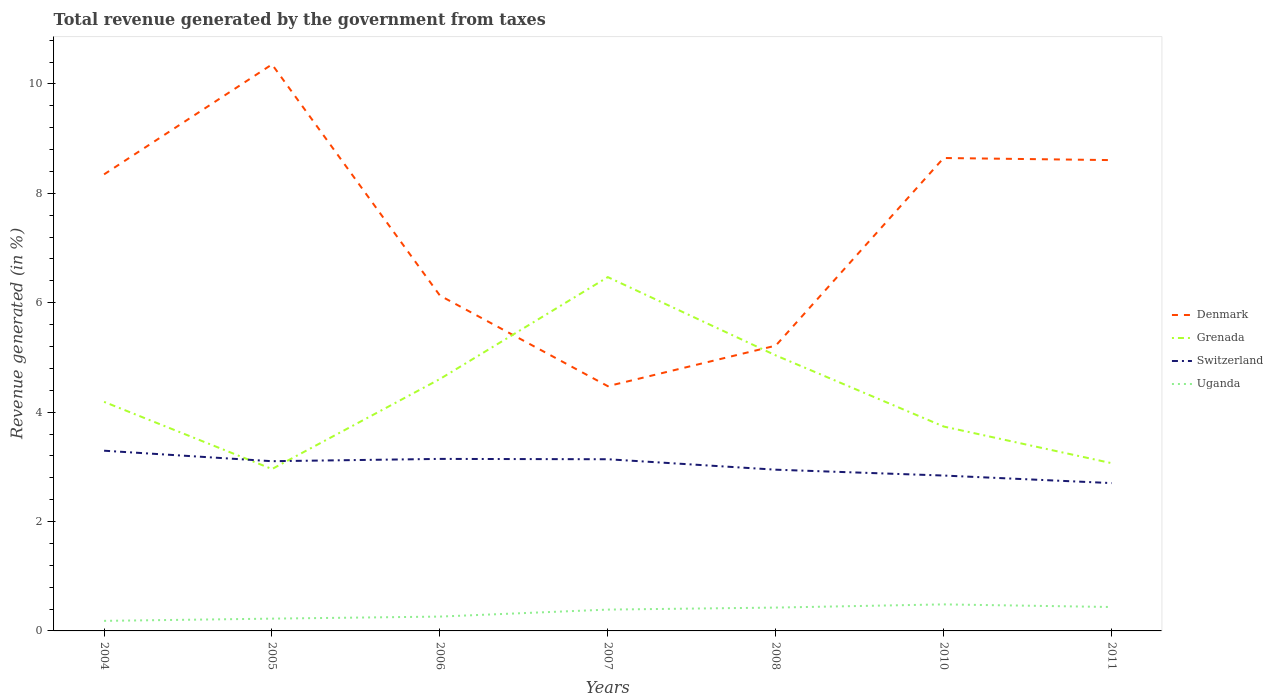How many different coloured lines are there?
Give a very brief answer. 4. Does the line corresponding to Denmark intersect with the line corresponding to Switzerland?
Your answer should be compact. No. Across all years, what is the maximum total revenue generated in Grenada?
Offer a very short reply. 2.96. What is the total total revenue generated in Uganda in the graph?
Provide a short and direct response. -0.21. What is the difference between the highest and the second highest total revenue generated in Denmark?
Your answer should be very brief. 5.88. How many lines are there?
Your response must be concise. 4. How many years are there in the graph?
Offer a very short reply. 7. What is the difference between two consecutive major ticks on the Y-axis?
Provide a succinct answer. 2. Does the graph contain any zero values?
Your answer should be compact. No. Where does the legend appear in the graph?
Give a very brief answer. Center right. How many legend labels are there?
Your response must be concise. 4. How are the legend labels stacked?
Offer a very short reply. Vertical. What is the title of the graph?
Your answer should be very brief. Total revenue generated by the government from taxes. What is the label or title of the Y-axis?
Offer a very short reply. Revenue generated (in %). What is the Revenue generated (in %) in Denmark in 2004?
Give a very brief answer. 8.35. What is the Revenue generated (in %) in Grenada in 2004?
Provide a succinct answer. 4.19. What is the Revenue generated (in %) in Switzerland in 2004?
Provide a succinct answer. 3.29. What is the Revenue generated (in %) of Uganda in 2004?
Make the answer very short. 0.18. What is the Revenue generated (in %) of Denmark in 2005?
Offer a terse response. 10.36. What is the Revenue generated (in %) of Grenada in 2005?
Make the answer very short. 2.96. What is the Revenue generated (in %) in Switzerland in 2005?
Offer a terse response. 3.1. What is the Revenue generated (in %) in Uganda in 2005?
Your answer should be compact. 0.22. What is the Revenue generated (in %) of Denmark in 2006?
Offer a very short reply. 6.13. What is the Revenue generated (in %) of Grenada in 2006?
Give a very brief answer. 4.61. What is the Revenue generated (in %) in Switzerland in 2006?
Make the answer very short. 3.15. What is the Revenue generated (in %) of Uganda in 2006?
Offer a terse response. 0.26. What is the Revenue generated (in %) of Denmark in 2007?
Keep it short and to the point. 4.47. What is the Revenue generated (in %) in Grenada in 2007?
Your answer should be compact. 6.47. What is the Revenue generated (in %) in Switzerland in 2007?
Provide a short and direct response. 3.14. What is the Revenue generated (in %) in Uganda in 2007?
Your response must be concise. 0.39. What is the Revenue generated (in %) of Denmark in 2008?
Provide a succinct answer. 5.22. What is the Revenue generated (in %) of Grenada in 2008?
Offer a very short reply. 5.04. What is the Revenue generated (in %) of Switzerland in 2008?
Offer a very short reply. 2.95. What is the Revenue generated (in %) of Uganda in 2008?
Ensure brevity in your answer.  0.43. What is the Revenue generated (in %) of Denmark in 2010?
Your answer should be compact. 8.65. What is the Revenue generated (in %) of Grenada in 2010?
Give a very brief answer. 3.74. What is the Revenue generated (in %) in Switzerland in 2010?
Keep it short and to the point. 2.84. What is the Revenue generated (in %) of Uganda in 2010?
Give a very brief answer. 0.49. What is the Revenue generated (in %) in Denmark in 2011?
Offer a very short reply. 8.61. What is the Revenue generated (in %) of Grenada in 2011?
Provide a short and direct response. 3.07. What is the Revenue generated (in %) in Switzerland in 2011?
Provide a succinct answer. 2.7. What is the Revenue generated (in %) of Uganda in 2011?
Give a very brief answer. 0.44. Across all years, what is the maximum Revenue generated (in %) in Denmark?
Provide a succinct answer. 10.36. Across all years, what is the maximum Revenue generated (in %) of Grenada?
Keep it short and to the point. 6.47. Across all years, what is the maximum Revenue generated (in %) of Switzerland?
Your answer should be very brief. 3.29. Across all years, what is the maximum Revenue generated (in %) of Uganda?
Your answer should be very brief. 0.49. Across all years, what is the minimum Revenue generated (in %) in Denmark?
Offer a very short reply. 4.47. Across all years, what is the minimum Revenue generated (in %) in Grenada?
Ensure brevity in your answer.  2.96. Across all years, what is the minimum Revenue generated (in %) in Switzerland?
Offer a very short reply. 2.7. Across all years, what is the minimum Revenue generated (in %) of Uganda?
Offer a very short reply. 0.18. What is the total Revenue generated (in %) in Denmark in the graph?
Provide a succinct answer. 51.78. What is the total Revenue generated (in %) in Grenada in the graph?
Provide a short and direct response. 30.06. What is the total Revenue generated (in %) of Switzerland in the graph?
Make the answer very short. 21.17. What is the total Revenue generated (in %) of Uganda in the graph?
Provide a short and direct response. 2.41. What is the difference between the Revenue generated (in %) of Denmark in 2004 and that in 2005?
Your answer should be very brief. -2.01. What is the difference between the Revenue generated (in %) in Grenada in 2004 and that in 2005?
Keep it short and to the point. 1.23. What is the difference between the Revenue generated (in %) in Switzerland in 2004 and that in 2005?
Ensure brevity in your answer.  0.19. What is the difference between the Revenue generated (in %) of Uganda in 2004 and that in 2005?
Provide a succinct answer. -0.04. What is the difference between the Revenue generated (in %) of Denmark in 2004 and that in 2006?
Your answer should be very brief. 2.22. What is the difference between the Revenue generated (in %) of Grenada in 2004 and that in 2006?
Offer a very short reply. -0.42. What is the difference between the Revenue generated (in %) of Switzerland in 2004 and that in 2006?
Make the answer very short. 0.15. What is the difference between the Revenue generated (in %) of Uganda in 2004 and that in 2006?
Offer a terse response. -0.08. What is the difference between the Revenue generated (in %) of Denmark in 2004 and that in 2007?
Your answer should be compact. 3.87. What is the difference between the Revenue generated (in %) of Grenada in 2004 and that in 2007?
Keep it short and to the point. -2.28. What is the difference between the Revenue generated (in %) in Switzerland in 2004 and that in 2007?
Provide a succinct answer. 0.16. What is the difference between the Revenue generated (in %) in Uganda in 2004 and that in 2007?
Provide a short and direct response. -0.21. What is the difference between the Revenue generated (in %) of Denmark in 2004 and that in 2008?
Make the answer very short. 3.13. What is the difference between the Revenue generated (in %) in Grenada in 2004 and that in 2008?
Offer a very short reply. -0.85. What is the difference between the Revenue generated (in %) in Switzerland in 2004 and that in 2008?
Offer a very short reply. 0.35. What is the difference between the Revenue generated (in %) of Uganda in 2004 and that in 2008?
Give a very brief answer. -0.24. What is the difference between the Revenue generated (in %) of Denmark in 2004 and that in 2010?
Keep it short and to the point. -0.3. What is the difference between the Revenue generated (in %) in Grenada in 2004 and that in 2010?
Your response must be concise. 0.45. What is the difference between the Revenue generated (in %) of Switzerland in 2004 and that in 2010?
Offer a terse response. 0.45. What is the difference between the Revenue generated (in %) in Uganda in 2004 and that in 2010?
Provide a succinct answer. -0.3. What is the difference between the Revenue generated (in %) in Denmark in 2004 and that in 2011?
Your response must be concise. -0.26. What is the difference between the Revenue generated (in %) in Grenada in 2004 and that in 2011?
Offer a very short reply. 1.12. What is the difference between the Revenue generated (in %) in Switzerland in 2004 and that in 2011?
Provide a succinct answer. 0.59. What is the difference between the Revenue generated (in %) of Uganda in 2004 and that in 2011?
Offer a terse response. -0.25. What is the difference between the Revenue generated (in %) of Denmark in 2005 and that in 2006?
Keep it short and to the point. 4.23. What is the difference between the Revenue generated (in %) in Grenada in 2005 and that in 2006?
Give a very brief answer. -1.65. What is the difference between the Revenue generated (in %) of Switzerland in 2005 and that in 2006?
Keep it short and to the point. -0.04. What is the difference between the Revenue generated (in %) of Uganda in 2005 and that in 2006?
Provide a succinct answer. -0.04. What is the difference between the Revenue generated (in %) of Denmark in 2005 and that in 2007?
Provide a succinct answer. 5.88. What is the difference between the Revenue generated (in %) of Grenada in 2005 and that in 2007?
Keep it short and to the point. -3.51. What is the difference between the Revenue generated (in %) in Switzerland in 2005 and that in 2007?
Give a very brief answer. -0.04. What is the difference between the Revenue generated (in %) of Uganda in 2005 and that in 2007?
Keep it short and to the point. -0.17. What is the difference between the Revenue generated (in %) in Denmark in 2005 and that in 2008?
Keep it short and to the point. 5.14. What is the difference between the Revenue generated (in %) of Grenada in 2005 and that in 2008?
Offer a terse response. -2.08. What is the difference between the Revenue generated (in %) in Switzerland in 2005 and that in 2008?
Your response must be concise. 0.16. What is the difference between the Revenue generated (in %) of Uganda in 2005 and that in 2008?
Your answer should be very brief. -0.2. What is the difference between the Revenue generated (in %) in Denmark in 2005 and that in 2010?
Your response must be concise. 1.71. What is the difference between the Revenue generated (in %) in Grenada in 2005 and that in 2010?
Ensure brevity in your answer.  -0.78. What is the difference between the Revenue generated (in %) of Switzerland in 2005 and that in 2010?
Your response must be concise. 0.26. What is the difference between the Revenue generated (in %) in Uganda in 2005 and that in 2010?
Offer a terse response. -0.26. What is the difference between the Revenue generated (in %) of Denmark in 2005 and that in 2011?
Offer a terse response. 1.75. What is the difference between the Revenue generated (in %) of Grenada in 2005 and that in 2011?
Your answer should be very brief. -0.11. What is the difference between the Revenue generated (in %) of Switzerland in 2005 and that in 2011?
Your response must be concise. 0.4. What is the difference between the Revenue generated (in %) of Uganda in 2005 and that in 2011?
Give a very brief answer. -0.21. What is the difference between the Revenue generated (in %) in Denmark in 2006 and that in 2007?
Offer a terse response. 1.66. What is the difference between the Revenue generated (in %) in Grenada in 2006 and that in 2007?
Your response must be concise. -1.86. What is the difference between the Revenue generated (in %) of Switzerland in 2006 and that in 2007?
Ensure brevity in your answer.  0.01. What is the difference between the Revenue generated (in %) of Uganda in 2006 and that in 2007?
Provide a short and direct response. -0.13. What is the difference between the Revenue generated (in %) in Denmark in 2006 and that in 2008?
Make the answer very short. 0.92. What is the difference between the Revenue generated (in %) of Grenada in 2006 and that in 2008?
Give a very brief answer. -0.43. What is the difference between the Revenue generated (in %) in Switzerland in 2006 and that in 2008?
Your answer should be compact. 0.2. What is the difference between the Revenue generated (in %) in Uganda in 2006 and that in 2008?
Provide a short and direct response. -0.16. What is the difference between the Revenue generated (in %) of Denmark in 2006 and that in 2010?
Your answer should be very brief. -2.51. What is the difference between the Revenue generated (in %) in Grenada in 2006 and that in 2010?
Ensure brevity in your answer.  0.87. What is the difference between the Revenue generated (in %) of Switzerland in 2006 and that in 2010?
Ensure brevity in your answer.  0.3. What is the difference between the Revenue generated (in %) in Uganda in 2006 and that in 2010?
Your response must be concise. -0.22. What is the difference between the Revenue generated (in %) in Denmark in 2006 and that in 2011?
Your response must be concise. -2.48. What is the difference between the Revenue generated (in %) of Grenada in 2006 and that in 2011?
Give a very brief answer. 1.54. What is the difference between the Revenue generated (in %) of Switzerland in 2006 and that in 2011?
Offer a very short reply. 0.44. What is the difference between the Revenue generated (in %) of Uganda in 2006 and that in 2011?
Provide a succinct answer. -0.17. What is the difference between the Revenue generated (in %) of Denmark in 2007 and that in 2008?
Offer a terse response. -0.74. What is the difference between the Revenue generated (in %) of Grenada in 2007 and that in 2008?
Your answer should be very brief. 1.43. What is the difference between the Revenue generated (in %) in Switzerland in 2007 and that in 2008?
Provide a succinct answer. 0.19. What is the difference between the Revenue generated (in %) in Uganda in 2007 and that in 2008?
Your answer should be compact. -0.04. What is the difference between the Revenue generated (in %) of Denmark in 2007 and that in 2010?
Provide a short and direct response. -4.17. What is the difference between the Revenue generated (in %) in Grenada in 2007 and that in 2010?
Your answer should be very brief. 2.73. What is the difference between the Revenue generated (in %) in Switzerland in 2007 and that in 2010?
Make the answer very short. 0.3. What is the difference between the Revenue generated (in %) in Uganda in 2007 and that in 2010?
Provide a succinct answer. -0.1. What is the difference between the Revenue generated (in %) in Denmark in 2007 and that in 2011?
Your answer should be compact. -4.13. What is the difference between the Revenue generated (in %) of Grenada in 2007 and that in 2011?
Provide a succinct answer. 3.4. What is the difference between the Revenue generated (in %) of Switzerland in 2007 and that in 2011?
Offer a terse response. 0.44. What is the difference between the Revenue generated (in %) in Uganda in 2007 and that in 2011?
Your answer should be compact. -0.05. What is the difference between the Revenue generated (in %) of Denmark in 2008 and that in 2010?
Provide a succinct answer. -3.43. What is the difference between the Revenue generated (in %) in Grenada in 2008 and that in 2010?
Your answer should be compact. 1.3. What is the difference between the Revenue generated (in %) of Switzerland in 2008 and that in 2010?
Make the answer very short. 0.11. What is the difference between the Revenue generated (in %) in Uganda in 2008 and that in 2010?
Give a very brief answer. -0.06. What is the difference between the Revenue generated (in %) in Denmark in 2008 and that in 2011?
Give a very brief answer. -3.39. What is the difference between the Revenue generated (in %) of Grenada in 2008 and that in 2011?
Keep it short and to the point. 1.97. What is the difference between the Revenue generated (in %) in Switzerland in 2008 and that in 2011?
Your answer should be very brief. 0.24. What is the difference between the Revenue generated (in %) of Uganda in 2008 and that in 2011?
Keep it short and to the point. -0.01. What is the difference between the Revenue generated (in %) in Denmark in 2010 and that in 2011?
Your response must be concise. 0.04. What is the difference between the Revenue generated (in %) of Grenada in 2010 and that in 2011?
Keep it short and to the point. 0.67. What is the difference between the Revenue generated (in %) in Switzerland in 2010 and that in 2011?
Give a very brief answer. 0.14. What is the difference between the Revenue generated (in %) in Uganda in 2010 and that in 2011?
Your response must be concise. 0.05. What is the difference between the Revenue generated (in %) in Denmark in 2004 and the Revenue generated (in %) in Grenada in 2005?
Offer a terse response. 5.39. What is the difference between the Revenue generated (in %) in Denmark in 2004 and the Revenue generated (in %) in Switzerland in 2005?
Provide a short and direct response. 5.24. What is the difference between the Revenue generated (in %) in Denmark in 2004 and the Revenue generated (in %) in Uganda in 2005?
Offer a terse response. 8.12. What is the difference between the Revenue generated (in %) of Grenada in 2004 and the Revenue generated (in %) of Switzerland in 2005?
Provide a succinct answer. 1.08. What is the difference between the Revenue generated (in %) in Grenada in 2004 and the Revenue generated (in %) in Uganda in 2005?
Offer a very short reply. 3.96. What is the difference between the Revenue generated (in %) in Switzerland in 2004 and the Revenue generated (in %) in Uganda in 2005?
Provide a short and direct response. 3.07. What is the difference between the Revenue generated (in %) in Denmark in 2004 and the Revenue generated (in %) in Grenada in 2006?
Your answer should be very brief. 3.74. What is the difference between the Revenue generated (in %) in Denmark in 2004 and the Revenue generated (in %) in Switzerland in 2006?
Give a very brief answer. 5.2. What is the difference between the Revenue generated (in %) of Denmark in 2004 and the Revenue generated (in %) of Uganda in 2006?
Your response must be concise. 8.09. What is the difference between the Revenue generated (in %) of Grenada in 2004 and the Revenue generated (in %) of Switzerland in 2006?
Provide a short and direct response. 1.04. What is the difference between the Revenue generated (in %) in Grenada in 2004 and the Revenue generated (in %) in Uganda in 2006?
Ensure brevity in your answer.  3.93. What is the difference between the Revenue generated (in %) of Switzerland in 2004 and the Revenue generated (in %) of Uganda in 2006?
Keep it short and to the point. 3.03. What is the difference between the Revenue generated (in %) in Denmark in 2004 and the Revenue generated (in %) in Grenada in 2007?
Ensure brevity in your answer.  1.88. What is the difference between the Revenue generated (in %) in Denmark in 2004 and the Revenue generated (in %) in Switzerland in 2007?
Your answer should be very brief. 5.21. What is the difference between the Revenue generated (in %) in Denmark in 2004 and the Revenue generated (in %) in Uganda in 2007?
Provide a succinct answer. 7.96. What is the difference between the Revenue generated (in %) of Grenada in 2004 and the Revenue generated (in %) of Switzerland in 2007?
Ensure brevity in your answer.  1.05. What is the difference between the Revenue generated (in %) of Grenada in 2004 and the Revenue generated (in %) of Uganda in 2007?
Give a very brief answer. 3.8. What is the difference between the Revenue generated (in %) in Switzerland in 2004 and the Revenue generated (in %) in Uganda in 2007?
Ensure brevity in your answer.  2.9. What is the difference between the Revenue generated (in %) in Denmark in 2004 and the Revenue generated (in %) in Grenada in 2008?
Provide a short and direct response. 3.31. What is the difference between the Revenue generated (in %) of Denmark in 2004 and the Revenue generated (in %) of Switzerland in 2008?
Keep it short and to the point. 5.4. What is the difference between the Revenue generated (in %) of Denmark in 2004 and the Revenue generated (in %) of Uganda in 2008?
Your answer should be compact. 7.92. What is the difference between the Revenue generated (in %) of Grenada in 2004 and the Revenue generated (in %) of Switzerland in 2008?
Your answer should be very brief. 1.24. What is the difference between the Revenue generated (in %) in Grenada in 2004 and the Revenue generated (in %) in Uganda in 2008?
Give a very brief answer. 3.76. What is the difference between the Revenue generated (in %) in Switzerland in 2004 and the Revenue generated (in %) in Uganda in 2008?
Your answer should be compact. 2.87. What is the difference between the Revenue generated (in %) in Denmark in 2004 and the Revenue generated (in %) in Grenada in 2010?
Give a very brief answer. 4.61. What is the difference between the Revenue generated (in %) of Denmark in 2004 and the Revenue generated (in %) of Switzerland in 2010?
Keep it short and to the point. 5.51. What is the difference between the Revenue generated (in %) of Denmark in 2004 and the Revenue generated (in %) of Uganda in 2010?
Your answer should be compact. 7.86. What is the difference between the Revenue generated (in %) of Grenada in 2004 and the Revenue generated (in %) of Switzerland in 2010?
Make the answer very short. 1.35. What is the difference between the Revenue generated (in %) in Grenada in 2004 and the Revenue generated (in %) in Uganda in 2010?
Offer a terse response. 3.7. What is the difference between the Revenue generated (in %) in Switzerland in 2004 and the Revenue generated (in %) in Uganda in 2010?
Your answer should be compact. 2.81. What is the difference between the Revenue generated (in %) of Denmark in 2004 and the Revenue generated (in %) of Grenada in 2011?
Offer a terse response. 5.28. What is the difference between the Revenue generated (in %) in Denmark in 2004 and the Revenue generated (in %) in Switzerland in 2011?
Offer a very short reply. 5.64. What is the difference between the Revenue generated (in %) of Denmark in 2004 and the Revenue generated (in %) of Uganda in 2011?
Your answer should be compact. 7.91. What is the difference between the Revenue generated (in %) of Grenada in 2004 and the Revenue generated (in %) of Switzerland in 2011?
Keep it short and to the point. 1.49. What is the difference between the Revenue generated (in %) of Grenada in 2004 and the Revenue generated (in %) of Uganda in 2011?
Offer a terse response. 3.75. What is the difference between the Revenue generated (in %) in Switzerland in 2004 and the Revenue generated (in %) in Uganda in 2011?
Offer a very short reply. 2.86. What is the difference between the Revenue generated (in %) in Denmark in 2005 and the Revenue generated (in %) in Grenada in 2006?
Your response must be concise. 5.75. What is the difference between the Revenue generated (in %) of Denmark in 2005 and the Revenue generated (in %) of Switzerland in 2006?
Offer a very short reply. 7.21. What is the difference between the Revenue generated (in %) in Denmark in 2005 and the Revenue generated (in %) in Uganda in 2006?
Provide a short and direct response. 10.1. What is the difference between the Revenue generated (in %) of Grenada in 2005 and the Revenue generated (in %) of Switzerland in 2006?
Keep it short and to the point. -0.19. What is the difference between the Revenue generated (in %) in Grenada in 2005 and the Revenue generated (in %) in Uganda in 2006?
Your response must be concise. 2.7. What is the difference between the Revenue generated (in %) in Switzerland in 2005 and the Revenue generated (in %) in Uganda in 2006?
Provide a short and direct response. 2.84. What is the difference between the Revenue generated (in %) of Denmark in 2005 and the Revenue generated (in %) of Grenada in 2007?
Your response must be concise. 3.89. What is the difference between the Revenue generated (in %) of Denmark in 2005 and the Revenue generated (in %) of Switzerland in 2007?
Offer a very short reply. 7.22. What is the difference between the Revenue generated (in %) in Denmark in 2005 and the Revenue generated (in %) in Uganda in 2007?
Offer a very short reply. 9.97. What is the difference between the Revenue generated (in %) in Grenada in 2005 and the Revenue generated (in %) in Switzerland in 2007?
Give a very brief answer. -0.18. What is the difference between the Revenue generated (in %) of Grenada in 2005 and the Revenue generated (in %) of Uganda in 2007?
Your answer should be very brief. 2.57. What is the difference between the Revenue generated (in %) in Switzerland in 2005 and the Revenue generated (in %) in Uganda in 2007?
Offer a terse response. 2.71. What is the difference between the Revenue generated (in %) in Denmark in 2005 and the Revenue generated (in %) in Grenada in 2008?
Make the answer very short. 5.32. What is the difference between the Revenue generated (in %) in Denmark in 2005 and the Revenue generated (in %) in Switzerland in 2008?
Provide a short and direct response. 7.41. What is the difference between the Revenue generated (in %) of Denmark in 2005 and the Revenue generated (in %) of Uganda in 2008?
Make the answer very short. 9.93. What is the difference between the Revenue generated (in %) of Grenada in 2005 and the Revenue generated (in %) of Switzerland in 2008?
Keep it short and to the point. 0.01. What is the difference between the Revenue generated (in %) of Grenada in 2005 and the Revenue generated (in %) of Uganda in 2008?
Make the answer very short. 2.53. What is the difference between the Revenue generated (in %) of Switzerland in 2005 and the Revenue generated (in %) of Uganda in 2008?
Make the answer very short. 2.68. What is the difference between the Revenue generated (in %) in Denmark in 2005 and the Revenue generated (in %) in Grenada in 2010?
Offer a terse response. 6.62. What is the difference between the Revenue generated (in %) in Denmark in 2005 and the Revenue generated (in %) in Switzerland in 2010?
Provide a succinct answer. 7.52. What is the difference between the Revenue generated (in %) in Denmark in 2005 and the Revenue generated (in %) in Uganda in 2010?
Your answer should be compact. 9.87. What is the difference between the Revenue generated (in %) of Grenada in 2005 and the Revenue generated (in %) of Switzerland in 2010?
Offer a very short reply. 0.12. What is the difference between the Revenue generated (in %) of Grenada in 2005 and the Revenue generated (in %) of Uganda in 2010?
Keep it short and to the point. 2.47. What is the difference between the Revenue generated (in %) of Switzerland in 2005 and the Revenue generated (in %) of Uganda in 2010?
Keep it short and to the point. 2.62. What is the difference between the Revenue generated (in %) of Denmark in 2005 and the Revenue generated (in %) of Grenada in 2011?
Offer a very short reply. 7.29. What is the difference between the Revenue generated (in %) of Denmark in 2005 and the Revenue generated (in %) of Switzerland in 2011?
Offer a very short reply. 7.65. What is the difference between the Revenue generated (in %) in Denmark in 2005 and the Revenue generated (in %) in Uganda in 2011?
Make the answer very short. 9.92. What is the difference between the Revenue generated (in %) in Grenada in 2005 and the Revenue generated (in %) in Switzerland in 2011?
Ensure brevity in your answer.  0.26. What is the difference between the Revenue generated (in %) in Grenada in 2005 and the Revenue generated (in %) in Uganda in 2011?
Offer a very short reply. 2.52. What is the difference between the Revenue generated (in %) in Switzerland in 2005 and the Revenue generated (in %) in Uganda in 2011?
Provide a short and direct response. 2.67. What is the difference between the Revenue generated (in %) in Denmark in 2006 and the Revenue generated (in %) in Grenada in 2007?
Make the answer very short. -0.34. What is the difference between the Revenue generated (in %) of Denmark in 2006 and the Revenue generated (in %) of Switzerland in 2007?
Keep it short and to the point. 2.99. What is the difference between the Revenue generated (in %) of Denmark in 2006 and the Revenue generated (in %) of Uganda in 2007?
Make the answer very short. 5.74. What is the difference between the Revenue generated (in %) of Grenada in 2006 and the Revenue generated (in %) of Switzerland in 2007?
Provide a succinct answer. 1.47. What is the difference between the Revenue generated (in %) in Grenada in 2006 and the Revenue generated (in %) in Uganda in 2007?
Provide a succinct answer. 4.22. What is the difference between the Revenue generated (in %) of Switzerland in 2006 and the Revenue generated (in %) of Uganda in 2007?
Give a very brief answer. 2.76. What is the difference between the Revenue generated (in %) of Denmark in 2006 and the Revenue generated (in %) of Grenada in 2008?
Keep it short and to the point. 1.09. What is the difference between the Revenue generated (in %) in Denmark in 2006 and the Revenue generated (in %) in Switzerland in 2008?
Provide a succinct answer. 3.18. What is the difference between the Revenue generated (in %) in Denmark in 2006 and the Revenue generated (in %) in Uganda in 2008?
Make the answer very short. 5.7. What is the difference between the Revenue generated (in %) of Grenada in 2006 and the Revenue generated (in %) of Switzerland in 2008?
Offer a terse response. 1.66. What is the difference between the Revenue generated (in %) of Grenada in 2006 and the Revenue generated (in %) of Uganda in 2008?
Keep it short and to the point. 4.18. What is the difference between the Revenue generated (in %) in Switzerland in 2006 and the Revenue generated (in %) in Uganda in 2008?
Your answer should be very brief. 2.72. What is the difference between the Revenue generated (in %) of Denmark in 2006 and the Revenue generated (in %) of Grenada in 2010?
Your answer should be very brief. 2.39. What is the difference between the Revenue generated (in %) in Denmark in 2006 and the Revenue generated (in %) in Switzerland in 2010?
Keep it short and to the point. 3.29. What is the difference between the Revenue generated (in %) of Denmark in 2006 and the Revenue generated (in %) of Uganda in 2010?
Provide a short and direct response. 5.65. What is the difference between the Revenue generated (in %) of Grenada in 2006 and the Revenue generated (in %) of Switzerland in 2010?
Your response must be concise. 1.76. What is the difference between the Revenue generated (in %) of Grenada in 2006 and the Revenue generated (in %) of Uganda in 2010?
Offer a very short reply. 4.12. What is the difference between the Revenue generated (in %) of Switzerland in 2006 and the Revenue generated (in %) of Uganda in 2010?
Ensure brevity in your answer.  2.66. What is the difference between the Revenue generated (in %) of Denmark in 2006 and the Revenue generated (in %) of Grenada in 2011?
Provide a succinct answer. 3.06. What is the difference between the Revenue generated (in %) in Denmark in 2006 and the Revenue generated (in %) in Switzerland in 2011?
Your response must be concise. 3.43. What is the difference between the Revenue generated (in %) of Denmark in 2006 and the Revenue generated (in %) of Uganda in 2011?
Make the answer very short. 5.69. What is the difference between the Revenue generated (in %) in Grenada in 2006 and the Revenue generated (in %) in Switzerland in 2011?
Your answer should be very brief. 1.9. What is the difference between the Revenue generated (in %) in Grenada in 2006 and the Revenue generated (in %) in Uganda in 2011?
Ensure brevity in your answer.  4.17. What is the difference between the Revenue generated (in %) of Switzerland in 2006 and the Revenue generated (in %) of Uganda in 2011?
Ensure brevity in your answer.  2.71. What is the difference between the Revenue generated (in %) of Denmark in 2007 and the Revenue generated (in %) of Grenada in 2008?
Provide a short and direct response. -0.56. What is the difference between the Revenue generated (in %) in Denmark in 2007 and the Revenue generated (in %) in Switzerland in 2008?
Keep it short and to the point. 1.53. What is the difference between the Revenue generated (in %) of Denmark in 2007 and the Revenue generated (in %) of Uganda in 2008?
Your answer should be compact. 4.05. What is the difference between the Revenue generated (in %) in Grenada in 2007 and the Revenue generated (in %) in Switzerland in 2008?
Provide a short and direct response. 3.52. What is the difference between the Revenue generated (in %) of Grenada in 2007 and the Revenue generated (in %) of Uganda in 2008?
Offer a very short reply. 6.04. What is the difference between the Revenue generated (in %) in Switzerland in 2007 and the Revenue generated (in %) in Uganda in 2008?
Make the answer very short. 2.71. What is the difference between the Revenue generated (in %) in Denmark in 2007 and the Revenue generated (in %) in Grenada in 2010?
Make the answer very short. 0.74. What is the difference between the Revenue generated (in %) in Denmark in 2007 and the Revenue generated (in %) in Switzerland in 2010?
Provide a succinct answer. 1.63. What is the difference between the Revenue generated (in %) in Denmark in 2007 and the Revenue generated (in %) in Uganda in 2010?
Give a very brief answer. 3.99. What is the difference between the Revenue generated (in %) in Grenada in 2007 and the Revenue generated (in %) in Switzerland in 2010?
Ensure brevity in your answer.  3.63. What is the difference between the Revenue generated (in %) in Grenada in 2007 and the Revenue generated (in %) in Uganda in 2010?
Your response must be concise. 5.98. What is the difference between the Revenue generated (in %) of Switzerland in 2007 and the Revenue generated (in %) of Uganda in 2010?
Provide a short and direct response. 2.65. What is the difference between the Revenue generated (in %) of Denmark in 2007 and the Revenue generated (in %) of Grenada in 2011?
Give a very brief answer. 1.41. What is the difference between the Revenue generated (in %) of Denmark in 2007 and the Revenue generated (in %) of Switzerland in 2011?
Your answer should be very brief. 1.77. What is the difference between the Revenue generated (in %) in Denmark in 2007 and the Revenue generated (in %) in Uganda in 2011?
Provide a succinct answer. 4.04. What is the difference between the Revenue generated (in %) of Grenada in 2007 and the Revenue generated (in %) of Switzerland in 2011?
Offer a very short reply. 3.77. What is the difference between the Revenue generated (in %) in Grenada in 2007 and the Revenue generated (in %) in Uganda in 2011?
Keep it short and to the point. 6.03. What is the difference between the Revenue generated (in %) of Switzerland in 2007 and the Revenue generated (in %) of Uganda in 2011?
Your answer should be very brief. 2.7. What is the difference between the Revenue generated (in %) of Denmark in 2008 and the Revenue generated (in %) of Grenada in 2010?
Offer a very short reply. 1.48. What is the difference between the Revenue generated (in %) in Denmark in 2008 and the Revenue generated (in %) in Switzerland in 2010?
Your answer should be very brief. 2.38. What is the difference between the Revenue generated (in %) of Denmark in 2008 and the Revenue generated (in %) of Uganda in 2010?
Make the answer very short. 4.73. What is the difference between the Revenue generated (in %) in Grenada in 2008 and the Revenue generated (in %) in Switzerland in 2010?
Ensure brevity in your answer.  2.2. What is the difference between the Revenue generated (in %) in Grenada in 2008 and the Revenue generated (in %) in Uganda in 2010?
Keep it short and to the point. 4.55. What is the difference between the Revenue generated (in %) in Switzerland in 2008 and the Revenue generated (in %) in Uganda in 2010?
Your response must be concise. 2.46. What is the difference between the Revenue generated (in %) in Denmark in 2008 and the Revenue generated (in %) in Grenada in 2011?
Your answer should be very brief. 2.15. What is the difference between the Revenue generated (in %) in Denmark in 2008 and the Revenue generated (in %) in Switzerland in 2011?
Make the answer very short. 2.51. What is the difference between the Revenue generated (in %) of Denmark in 2008 and the Revenue generated (in %) of Uganda in 2011?
Ensure brevity in your answer.  4.78. What is the difference between the Revenue generated (in %) in Grenada in 2008 and the Revenue generated (in %) in Switzerland in 2011?
Provide a succinct answer. 2.33. What is the difference between the Revenue generated (in %) of Grenada in 2008 and the Revenue generated (in %) of Uganda in 2011?
Your answer should be very brief. 4.6. What is the difference between the Revenue generated (in %) of Switzerland in 2008 and the Revenue generated (in %) of Uganda in 2011?
Your answer should be very brief. 2.51. What is the difference between the Revenue generated (in %) in Denmark in 2010 and the Revenue generated (in %) in Grenada in 2011?
Make the answer very short. 5.58. What is the difference between the Revenue generated (in %) of Denmark in 2010 and the Revenue generated (in %) of Switzerland in 2011?
Give a very brief answer. 5.94. What is the difference between the Revenue generated (in %) of Denmark in 2010 and the Revenue generated (in %) of Uganda in 2011?
Your response must be concise. 8.21. What is the difference between the Revenue generated (in %) of Grenada in 2010 and the Revenue generated (in %) of Switzerland in 2011?
Your answer should be very brief. 1.03. What is the difference between the Revenue generated (in %) in Grenada in 2010 and the Revenue generated (in %) in Uganda in 2011?
Your answer should be very brief. 3.3. What is the difference between the Revenue generated (in %) of Switzerland in 2010 and the Revenue generated (in %) of Uganda in 2011?
Keep it short and to the point. 2.4. What is the average Revenue generated (in %) of Denmark per year?
Your answer should be compact. 7.4. What is the average Revenue generated (in %) in Grenada per year?
Make the answer very short. 4.29. What is the average Revenue generated (in %) of Switzerland per year?
Provide a short and direct response. 3.02. What is the average Revenue generated (in %) in Uganda per year?
Provide a succinct answer. 0.34. In the year 2004, what is the difference between the Revenue generated (in %) in Denmark and Revenue generated (in %) in Grenada?
Your response must be concise. 4.16. In the year 2004, what is the difference between the Revenue generated (in %) in Denmark and Revenue generated (in %) in Switzerland?
Offer a very short reply. 5.05. In the year 2004, what is the difference between the Revenue generated (in %) in Denmark and Revenue generated (in %) in Uganda?
Ensure brevity in your answer.  8.16. In the year 2004, what is the difference between the Revenue generated (in %) of Grenada and Revenue generated (in %) of Switzerland?
Provide a short and direct response. 0.89. In the year 2004, what is the difference between the Revenue generated (in %) of Grenada and Revenue generated (in %) of Uganda?
Make the answer very short. 4. In the year 2004, what is the difference between the Revenue generated (in %) of Switzerland and Revenue generated (in %) of Uganda?
Make the answer very short. 3.11. In the year 2005, what is the difference between the Revenue generated (in %) in Denmark and Revenue generated (in %) in Grenada?
Provide a succinct answer. 7.4. In the year 2005, what is the difference between the Revenue generated (in %) of Denmark and Revenue generated (in %) of Switzerland?
Ensure brevity in your answer.  7.25. In the year 2005, what is the difference between the Revenue generated (in %) in Denmark and Revenue generated (in %) in Uganda?
Your response must be concise. 10.13. In the year 2005, what is the difference between the Revenue generated (in %) of Grenada and Revenue generated (in %) of Switzerland?
Your answer should be compact. -0.14. In the year 2005, what is the difference between the Revenue generated (in %) in Grenada and Revenue generated (in %) in Uganda?
Your answer should be compact. 2.74. In the year 2005, what is the difference between the Revenue generated (in %) of Switzerland and Revenue generated (in %) of Uganda?
Your answer should be very brief. 2.88. In the year 2006, what is the difference between the Revenue generated (in %) of Denmark and Revenue generated (in %) of Grenada?
Offer a terse response. 1.53. In the year 2006, what is the difference between the Revenue generated (in %) of Denmark and Revenue generated (in %) of Switzerland?
Ensure brevity in your answer.  2.99. In the year 2006, what is the difference between the Revenue generated (in %) of Denmark and Revenue generated (in %) of Uganda?
Offer a very short reply. 5.87. In the year 2006, what is the difference between the Revenue generated (in %) in Grenada and Revenue generated (in %) in Switzerland?
Provide a succinct answer. 1.46. In the year 2006, what is the difference between the Revenue generated (in %) in Grenada and Revenue generated (in %) in Uganda?
Your response must be concise. 4.34. In the year 2006, what is the difference between the Revenue generated (in %) of Switzerland and Revenue generated (in %) of Uganda?
Provide a succinct answer. 2.88. In the year 2007, what is the difference between the Revenue generated (in %) of Denmark and Revenue generated (in %) of Grenada?
Provide a succinct answer. -1.99. In the year 2007, what is the difference between the Revenue generated (in %) in Denmark and Revenue generated (in %) in Switzerland?
Provide a succinct answer. 1.34. In the year 2007, what is the difference between the Revenue generated (in %) of Denmark and Revenue generated (in %) of Uganda?
Provide a short and direct response. 4.08. In the year 2007, what is the difference between the Revenue generated (in %) of Grenada and Revenue generated (in %) of Switzerland?
Provide a short and direct response. 3.33. In the year 2007, what is the difference between the Revenue generated (in %) of Grenada and Revenue generated (in %) of Uganda?
Provide a short and direct response. 6.08. In the year 2007, what is the difference between the Revenue generated (in %) in Switzerland and Revenue generated (in %) in Uganda?
Your answer should be very brief. 2.75. In the year 2008, what is the difference between the Revenue generated (in %) of Denmark and Revenue generated (in %) of Grenada?
Offer a very short reply. 0.18. In the year 2008, what is the difference between the Revenue generated (in %) in Denmark and Revenue generated (in %) in Switzerland?
Offer a terse response. 2.27. In the year 2008, what is the difference between the Revenue generated (in %) of Denmark and Revenue generated (in %) of Uganda?
Your answer should be compact. 4.79. In the year 2008, what is the difference between the Revenue generated (in %) of Grenada and Revenue generated (in %) of Switzerland?
Your response must be concise. 2.09. In the year 2008, what is the difference between the Revenue generated (in %) of Grenada and Revenue generated (in %) of Uganda?
Make the answer very short. 4.61. In the year 2008, what is the difference between the Revenue generated (in %) of Switzerland and Revenue generated (in %) of Uganda?
Your answer should be compact. 2.52. In the year 2010, what is the difference between the Revenue generated (in %) in Denmark and Revenue generated (in %) in Grenada?
Your answer should be compact. 4.91. In the year 2010, what is the difference between the Revenue generated (in %) in Denmark and Revenue generated (in %) in Switzerland?
Your answer should be very brief. 5.81. In the year 2010, what is the difference between the Revenue generated (in %) of Denmark and Revenue generated (in %) of Uganda?
Provide a succinct answer. 8.16. In the year 2010, what is the difference between the Revenue generated (in %) of Grenada and Revenue generated (in %) of Switzerland?
Provide a succinct answer. 0.9. In the year 2010, what is the difference between the Revenue generated (in %) of Grenada and Revenue generated (in %) of Uganda?
Your answer should be compact. 3.25. In the year 2010, what is the difference between the Revenue generated (in %) of Switzerland and Revenue generated (in %) of Uganda?
Keep it short and to the point. 2.36. In the year 2011, what is the difference between the Revenue generated (in %) of Denmark and Revenue generated (in %) of Grenada?
Offer a terse response. 5.54. In the year 2011, what is the difference between the Revenue generated (in %) in Denmark and Revenue generated (in %) in Switzerland?
Make the answer very short. 5.91. In the year 2011, what is the difference between the Revenue generated (in %) in Denmark and Revenue generated (in %) in Uganda?
Offer a terse response. 8.17. In the year 2011, what is the difference between the Revenue generated (in %) in Grenada and Revenue generated (in %) in Switzerland?
Your answer should be very brief. 0.36. In the year 2011, what is the difference between the Revenue generated (in %) in Grenada and Revenue generated (in %) in Uganda?
Offer a very short reply. 2.63. In the year 2011, what is the difference between the Revenue generated (in %) of Switzerland and Revenue generated (in %) of Uganda?
Your answer should be very brief. 2.27. What is the ratio of the Revenue generated (in %) in Denmark in 2004 to that in 2005?
Your answer should be compact. 0.81. What is the ratio of the Revenue generated (in %) of Grenada in 2004 to that in 2005?
Offer a very short reply. 1.41. What is the ratio of the Revenue generated (in %) of Switzerland in 2004 to that in 2005?
Your response must be concise. 1.06. What is the ratio of the Revenue generated (in %) of Uganda in 2004 to that in 2005?
Give a very brief answer. 0.82. What is the ratio of the Revenue generated (in %) in Denmark in 2004 to that in 2006?
Provide a succinct answer. 1.36. What is the ratio of the Revenue generated (in %) in Grenada in 2004 to that in 2006?
Offer a terse response. 0.91. What is the ratio of the Revenue generated (in %) in Switzerland in 2004 to that in 2006?
Offer a terse response. 1.05. What is the ratio of the Revenue generated (in %) in Uganda in 2004 to that in 2006?
Your response must be concise. 0.7. What is the ratio of the Revenue generated (in %) of Denmark in 2004 to that in 2007?
Provide a succinct answer. 1.87. What is the ratio of the Revenue generated (in %) of Grenada in 2004 to that in 2007?
Provide a short and direct response. 0.65. What is the ratio of the Revenue generated (in %) in Switzerland in 2004 to that in 2007?
Keep it short and to the point. 1.05. What is the ratio of the Revenue generated (in %) of Uganda in 2004 to that in 2007?
Make the answer very short. 0.47. What is the ratio of the Revenue generated (in %) in Denmark in 2004 to that in 2008?
Offer a terse response. 1.6. What is the ratio of the Revenue generated (in %) of Grenada in 2004 to that in 2008?
Keep it short and to the point. 0.83. What is the ratio of the Revenue generated (in %) of Switzerland in 2004 to that in 2008?
Provide a succinct answer. 1.12. What is the ratio of the Revenue generated (in %) in Uganda in 2004 to that in 2008?
Offer a very short reply. 0.43. What is the ratio of the Revenue generated (in %) in Denmark in 2004 to that in 2010?
Ensure brevity in your answer.  0.97. What is the ratio of the Revenue generated (in %) of Grenada in 2004 to that in 2010?
Offer a terse response. 1.12. What is the ratio of the Revenue generated (in %) of Switzerland in 2004 to that in 2010?
Offer a terse response. 1.16. What is the ratio of the Revenue generated (in %) of Uganda in 2004 to that in 2010?
Your answer should be very brief. 0.38. What is the ratio of the Revenue generated (in %) in Denmark in 2004 to that in 2011?
Keep it short and to the point. 0.97. What is the ratio of the Revenue generated (in %) in Grenada in 2004 to that in 2011?
Provide a short and direct response. 1.37. What is the ratio of the Revenue generated (in %) of Switzerland in 2004 to that in 2011?
Provide a succinct answer. 1.22. What is the ratio of the Revenue generated (in %) in Uganda in 2004 to that in 2011?
Make the answer very short. 0.42. What is the ratio of the Revenue generated (in %) of Denmark in 2005 to that in 2006?
Provide a short and direct response. 1.69. What is the ratio of the Revenue generated (in %) in Grenada in 2005 to that in 2006?
Keep it short and to the point. 0.64. What is the ratio of the Revenue generated (in %) of Switzerland in 2005 to that in 2006?
Provide a succinct answer. 0.99. What is the ratio of the Revenue generated (in %) of Uganda in 2005 to that in 2006?
Provide a succinct answer. 0.86. What is the ratio of the Revenue generated (in %) of Denmark in 2005 to that in 2007?
Your answer should be compact. 2.31. What is the ratio of the Revenue generated (in %) in Grenada in 2005 to that in 2007?
Your answer should be compact. 0.46. What is the ratio of the Revenue generated (in %) in Uganda in 2005 to that in 2007?
Your answer should be compact. 0.58. What is the ratio of the Revenue generated (in %) in Denmark in 2005 to that in 2008?
Your response must be concise. 1.99. What is the ratio of the Revenue generated (in %) in Grenada in 2005 to that in 2008?
Keep it short and to the point. 0.59. What is the ratio of the Revenue generated (in %) in Switzerland in 2005 to that in 2008?
Make the answer very short. 1.05. What is the ratio of the Revenue generated (in %) of Uganda in 2005 to that in 2008?
Your answer should be very brief. 0.53. What is the ratio of the Revenue generated (in %) of Denmark in 2005 to that in 2010?
Provide a short and direct response. 1.2. What is the ratio of the Revenue generated (in %) in Grenada in 2005 to that in 2010?
Give a very brief answer. 0.79. What is the ratio of the Revenue generated (in %) of Switzerland in 2005 to that in 2010?
Make the answer very short. 1.09. What is the ratio of the Revenue generated (in %) in Uganda in 2005 to that in 2010?
Provide a succinct answer. 0.46. What is the ratio of the Revenue generated (in %) in Denmark in 2005 to that in 2011?
Your answer should be compact. 1.2. What is the ratio of the Revenue generated (in %) of Grenada in 2005 to that in 2011?
Make the answer very short. 0.96. What is the ratio of the Revenue generated (in %) of Switzerland in 2005 to that in 2011?
Ensure brevity in your answer.  1.15. What is the ratio of the Revenue generated (in %) in Uganda in 2005 to that in 2011?
Offer a very short reply. 0.51. What is the ratio of the Revenue generated (in %) of Denmark in 2006 to that in 2007?
Provide a short and direct response. 1.37. What is the ratio of the Revenue generated (in %) in Grenada in 2006 to that in 2007?
Your answer should be very brief. 0.71. What is the ratio of the Revenue generated (in %) of Uganda in 2006 to that in 2007?
Your answer should be compact. 0.67. What is the ratio of the Revenue generated (in %) of Denmark in 2006 to that in 2008?
Provide a short and direct response. 1.18. What is the ratio of the Revenue generated (in %) in Grenada in 2006 to that in 2008?
Ensure brevity in your answer.  0.91. What is the ratio of the Revenue generated (in %) in Switzerland in 2006 to that in 2008?
Provide a succinct answer. 1.07. What is the ratio of the Revenue generated (in %) of Uganda in 2006 to that in 2008?
Your response must be concise. 0.61. What is the ratio of the Revenue generated (in %) in Denmark in 2006 to that in 2010?
Keep it short and to the point. 0.71. What is the ratio of the Revenue generated (in %) in Grenada in 2006 to that in 2010?
Ensure brevity in your answer.  1.23. What is the ratio of the Revenue generated (in %) of Switzerland in 2006 to that in 2010?
Give a very brief answer. 1.11. What is the ratio of the Revenue generated (in %) of Uganda in 2006 to that in 2010?
Your response must be concise. 0.54. What is the ratio of the Revenue generated (in %) in Denmark in 2006 to that in 2011?
Ensure brevity in your answer.  0.71. What is the ratio of the Revenue generated (in %) in Grenada in 2006 to that in 2011?
Offer a very short reply. 1.5. What is the ratio of the Revenue generated (in %) in Switzerland in 2006 to that in 2011?
Your answer should be very brief. 1.16. What is the ratio of the Revenue generated (in %) in Uganda in 2006 to that in 2011?
Keep it short and to the point. 0.6. What is the ratio of the Revenue generated (in %) in Denmark in 2007 to that in 2008?
Your response must be concise. 0.86. What is the ratio of the Revenue generated (in %) of Grenada in 2007 to that in 2008?
Your answer should be very brief. 1.28. What is the ratio of the Revenue generated (in %) of Switzerland in 2007 to that in 2008?
Make the answer very short. 1.06. What is the ratio of the Revenue generated (in %) of Uganda in 2007 to that in 2008?
Make the answer very short. 0.91. What is the ratio of the Revenue generated (in %) in Denmark in 2007 to that in 2010?
Your answer should be compact. 0.52. What is the ratio of the Revenue generated (in %) of Grenada in 2007 to that in 2010?
Give a very brief answer. 1.73. What is the ratio of the Revenue generated (in %) of Switzerland in 2007 to that in 2010?
Ensure brevity in your answer.  1.1. What is the ratio of the Revenue generated (in %) of Uganda in 2007 to that in 2010?
Your answer should be compact. 0.8. What is the ratio of the Revenue generated (in %) in Denmark in 2007 to that in 2011?
Keep it short and to the point. 0.52. What is the ratio of the Revenue generated (in %) in Grenada in 2007 to that in 2011?
Offer a terse response. 2.11. What is the ratio of the Revenue generated (in %) in Switzerland in 2007 to that in 2011?
Your answer should be very brief. 1.16. What is the ratio of the Revenue generated (in %) in Uganda in 2007 to that in 2011?
Keep it short and to the point. 0.89. What is the ratio of the Revenue generated (in %) in Denmark in 2008 to that in 2010?
Give a very brief answer. 0.6. What is the ratio of the Revenue generated (in %) in Grenada in 2008 to that in 2010?
Your response must be concise. 1.35. What is the ratio of the Revenue generated (in %) in Switzerland in 2008 to that in 2010?
Provide a short and direct response. 1.04. What is the ratio of the Revenue generated (in %) in Uganda in 2008 to that in 2010?
Give a very brief answer. 0.88. What is the ratio of the Revenue generated (in %) of Denmark in 2008 to that in 2011?
Keep it short and to the point. 0.61. What is the ratio of the Revenue generated (in %) of Grenada in 2008 to that in 2011?
Offer a very short reply. 1.64. What is the ratio of the Revenue generated (in %) of Switzerland in 2008 to that in 2011?
Your answer should be very brief. 1.09. What is the ratio of the Revenue generated (in %) in Uganda in 2008 to that in 2011?
Provide a short and direct response. 0.98. What is the ratio of the Revenue generated (in %) in Grenada in 2010 to that in 2011?
Provide a short and direct response. 1.22. What is the ratio of the Revenue generated (in %) in Switzerland in 2010 to that in 2011?
Make the answer very short. 1.05. What is the ratio of the Revenue generated (in %) in Uganda in 2010 to that in 2011?
Offer a terse response. 1.11. What is the difference between the highest and the second highest Revenue generated (in %) of Denmark?
Offer a terse response. 1.71. What is the difference between the highest and the second highest Revenue generated (in %) in Grenada?
Your answer should be compact. 1.43. What is the difference between the highest and the second highest Revenue generated (in %) of Switzerland?
Your answer should be very brief. 0.15. What is the difference between the highest and the second highest Revenue generated (in %) in Uganda?
Keep it short and to the point. 0.05. What is the difference between the highest and the lowest Revenue generated (in %) of Denmark?
Give a very brief answer. 5.88. What is the difference between the highest and the lowest Revenue generated (in %) in Grenada?
Your answer should be compact. 3.51. What is the difference between the highest and the lowest Revenue generated (in %) in Switzerland?
Your response must be concise. 0.59. What is the difference between the highest and the lowest Revenue generated (in %) of Uganda?
Keep it short and to the point. 0.3. 